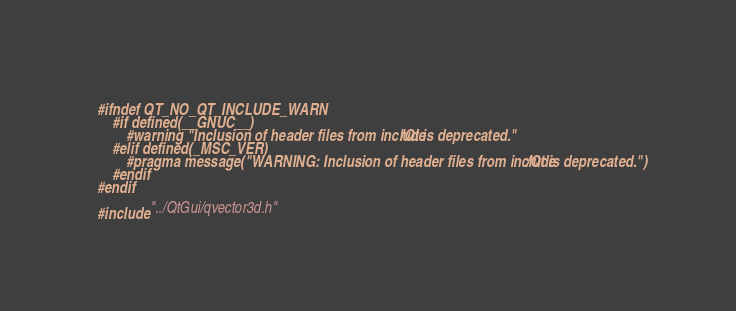Convert code to text. <code><loc_0><loc_0><loc_500><loc_500><_C_>#ifndef QT_NO_QT_INCLUDE_WARN
    #if defined(__GNUC__)
        #warning "Inclusion of header files from include/Qt is deprecated."
    #elif defined(_MSC_VER)
        #pragma message("WARNING: Inclusion of header files from include/Qt is deprecated.")
    #endif
#endif

#include "../QtGui/qvector3d.h"
</code> 